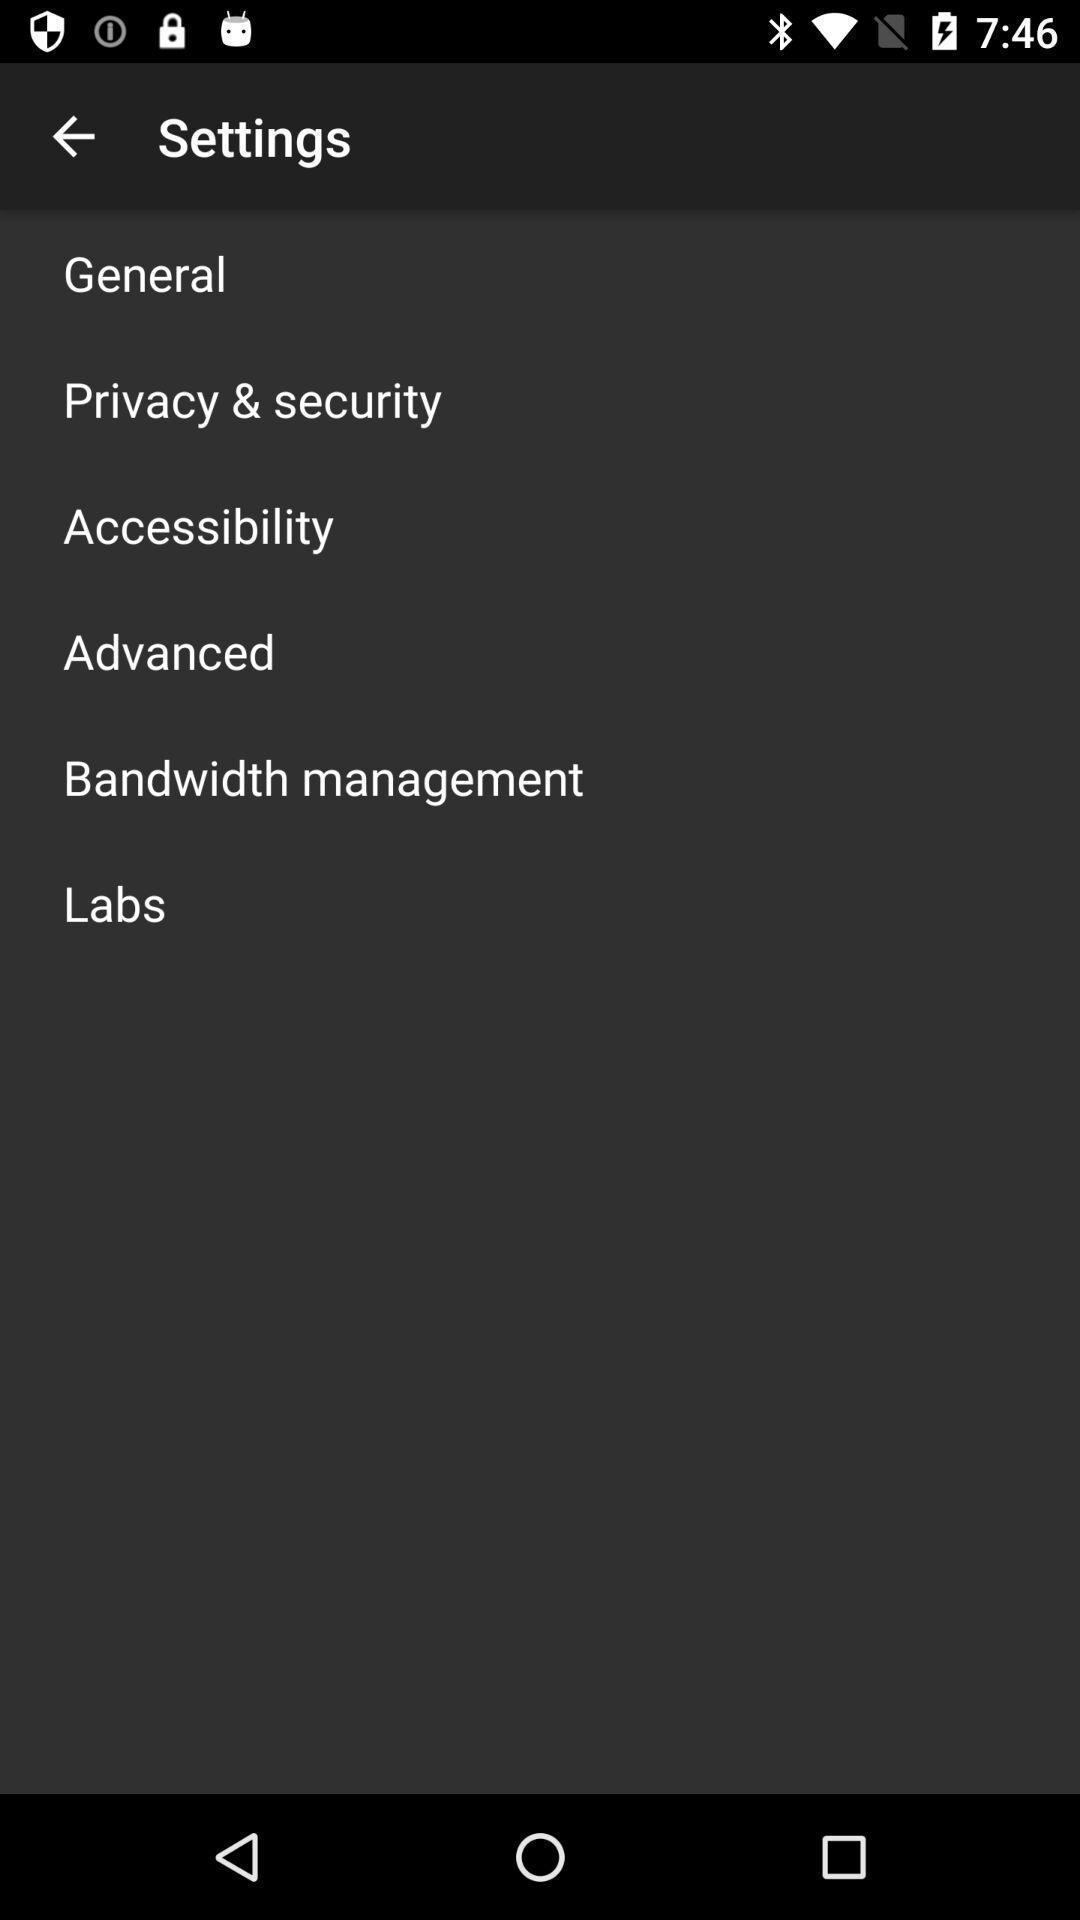Explain what's happening in this screen capture. Screen shows settings. 